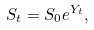<formula> <loc_0><loc_0><loc_500><loc_500>S _ { t } = S _ { 0 } e ^ { Y _ { t } } ,</formula> 